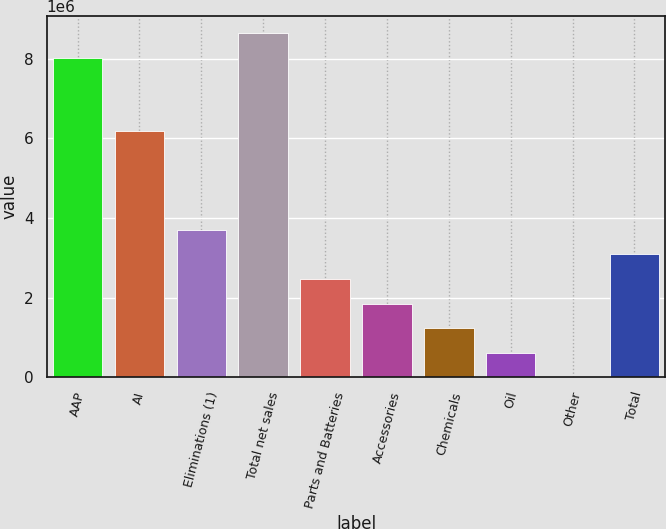<chart> <loc_0><loc_0><loc_500><loc_500><bar_chart><fcel>AAP<fcel>AI<fcel>Eliminations (1)<fcel>Total net sales<fcel>Parts and Batteries<fcel>Accessories<fcel>Chemicals<fcel>Oil<fcel>Other<fcel>Total<nl><fcel>8.0216e+06<fcel>6.17046e+06<fcel>3.70228e+06<fcel>8.63865e+06<fcel>2.46819e+06<fcel>1.85114e+06<fcel>1.23409e+06<fcel>617048<fcel>2<fcel>3.08523e+06<nl></chart> 